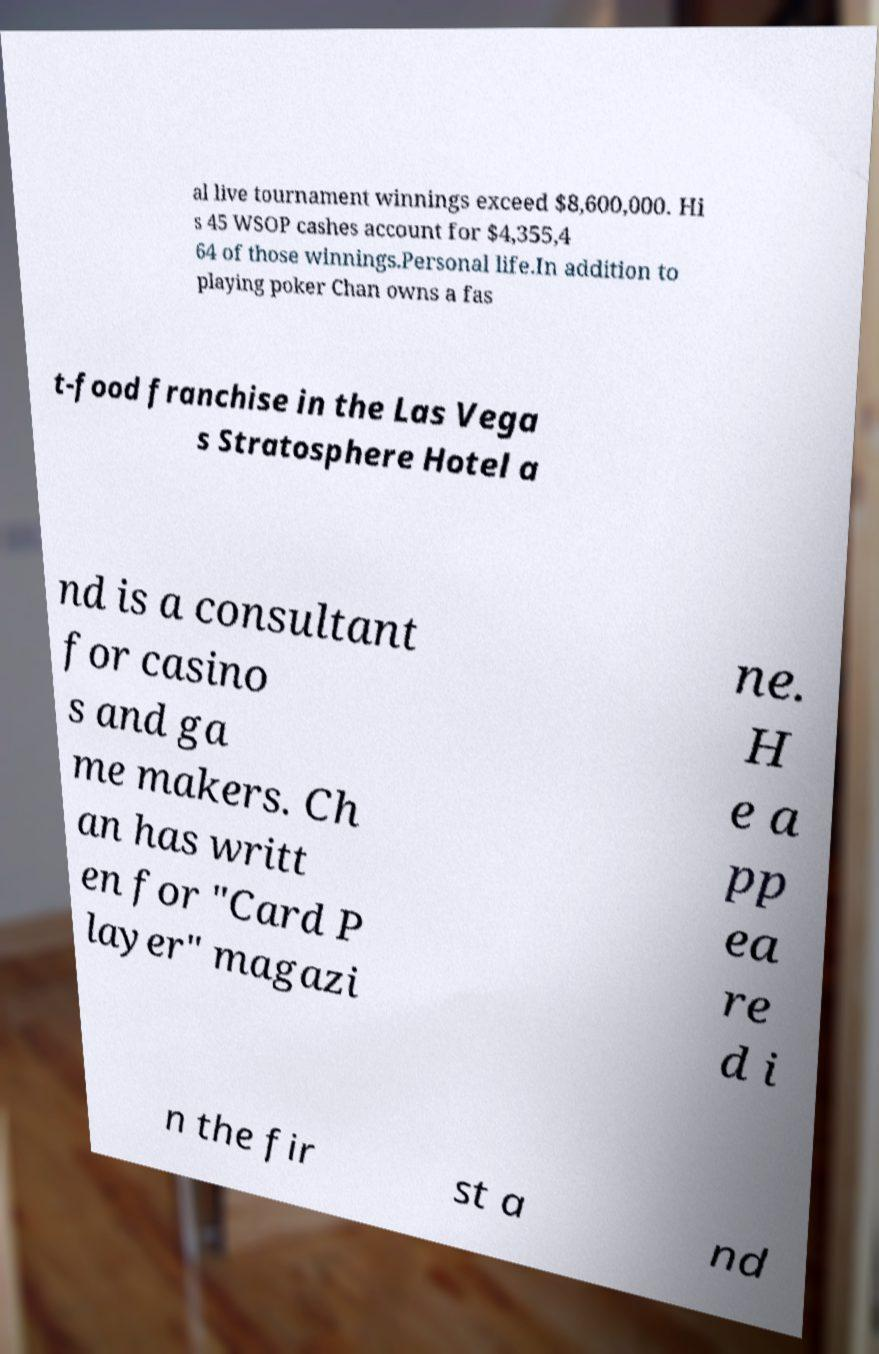Could you assist in decoding the text presented in this image and type it out clearly? al live tournament winnings exceed $8,600,000. Hi s 45 WSOP cashes account for $4,355,4 64 of those winnings.Personal life.In addition to playing poker Chan owns a fas t-food franchise in the Las Vega s Stratosphere Hotel a nd is a consultant for casino s and ga me makers. Ch an has writt en for "Card P layer" magazi ne. H e a pp ea re d i n the fir st a nd 